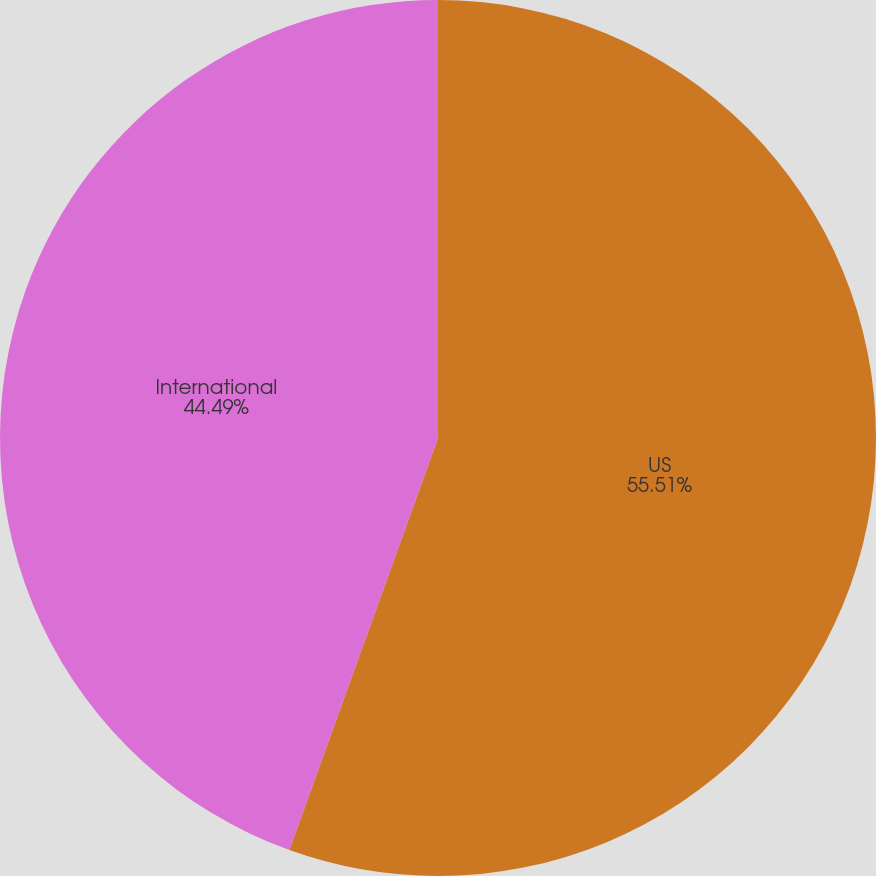<chart> <loc_0><loc_0><loc_500><loc_500><pie_chart><fcel>US<fcel>International<nl><fcel>55.51%<fcel>44.49%<nl></chart> 